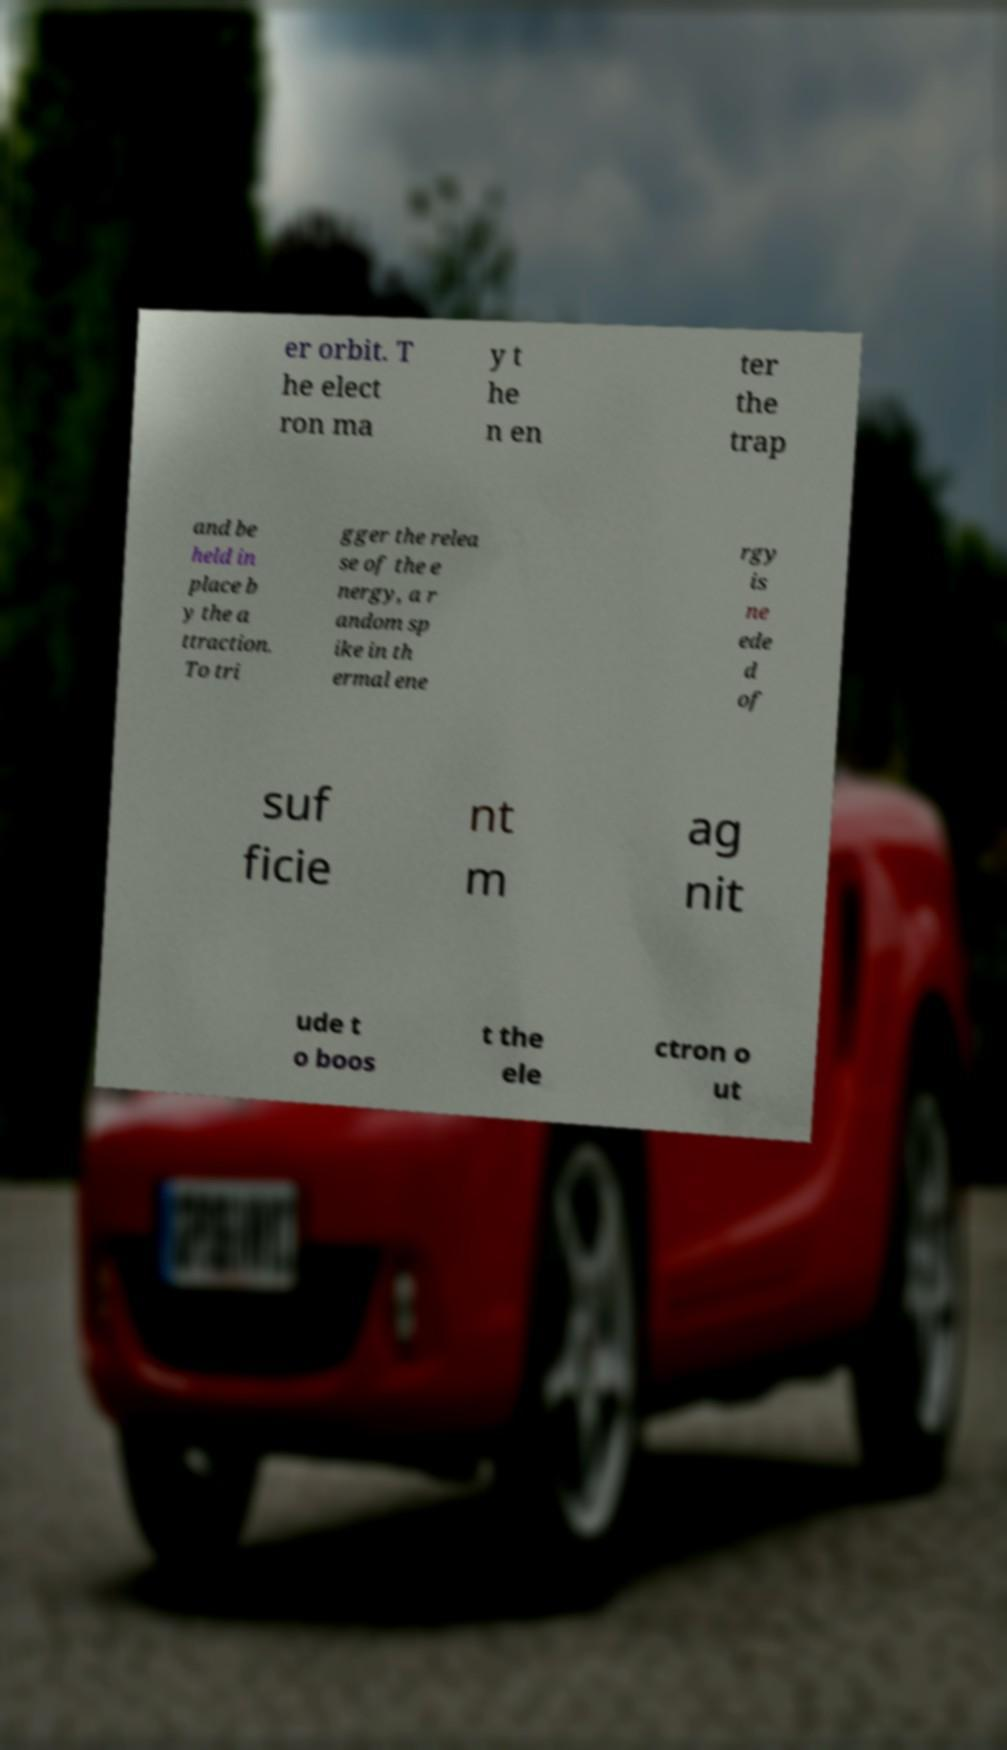For documentation purposes, I need the text within this image transcribed. Could you provide that? er orbit. T he elect ron ma y t he n en ter the trap and be held in place b y the a ttraction. To tri gger the relea se of the e nergy, a r andom sp ike in th ermal ene rgy is ne ede d of suf ficie nt m ag nit ude t o boos t the ele ctron o ut 